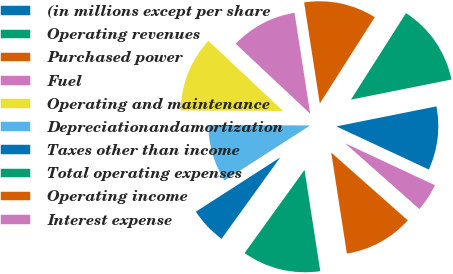<chart> <loc_0><loc_0><loc_500><loc_500><pie_chart><fcel>(in millions except per share<fcel>Operating revenues<fcel>Purchased power<fcel>Fuel<fcel>Operating and maintenance<fcel>Depreciationandamortization<fcel>Taxes other than income<fcel>Total operating expenses<fcel>Operating income<fcel>Interest expense<nl><fcel>10.09%<fcel>12.84%<fcel>11.47%<fcel>10.55%<fcel>11.93%<fcel>9.17%<fcel>5.96%<fcel>12.39%<fcel>11.01%<fcel>4.59%<nl></chart> 